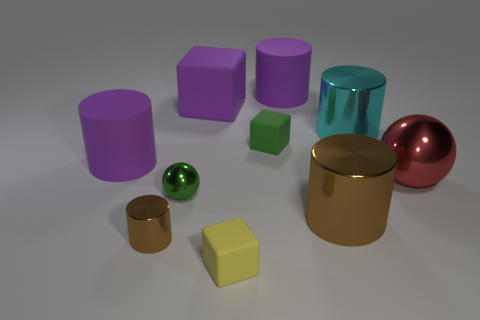What number of other objects are there of the same color as the big metallic ball?
Your answer should be compact. 0. The cube in front of the small cube that is behind the large brown cylinder is made of what material?
Your answer should be compact. Rubber. Is there a tiny purple block?
Offer a terse response. No. What size is the cylinder behind the metallic cylinder that is behind the big ball?
Offer a terse response. Large. Are there more large purple cylinders that are in front of the small brown metal object than small spheres that are behind the cyan shiny object?
Your response must be concise. No. How many cylinders are cyan objects or green shiny things?
Give a very brief answer. 1. Is there anything else that has the same size as the purple cube?
Offer a very short reply. Yes. There is a brown thing right of the green shiny sphere; is it the same shape as the green rubber object?
Your response must be concise. No. The small metallic cylinder is what color?
Your response must be concise. Brown. There is another small rubber thing that is the same shape as the yellow object; what color is it?
Keep it short and to the point. Green. 